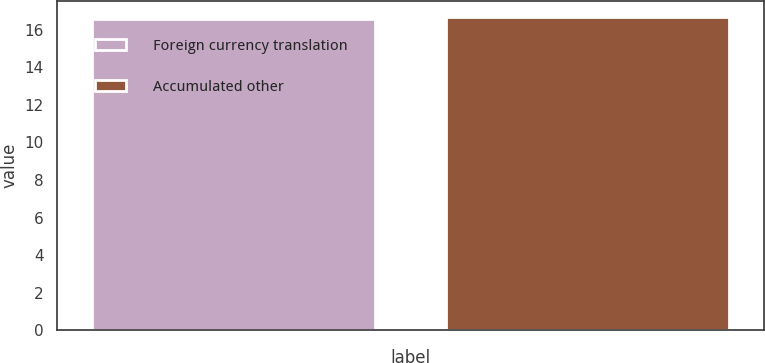Convert chart to OTSL. <chart><loc_0><loc_0><loc_500><loc_500><bar_chart><fcel>Foreign currency translation<fcel>Accumulated other<nl><fcel>16.6<fcel>16.7<nl></chart> 